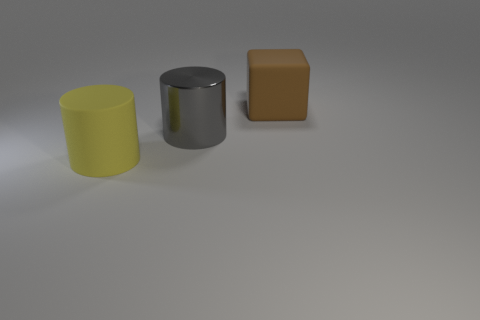What is the material of the gray thing?
Your answer should be compact. Metal. There is a gray cylinder that is the same size as the brown rubber object; what is it made of?
Your response must be concise. Metal. Is there a gray cube of the same size as the yellow matte object?
Your answer should be compact. No. Are there the same number of large yellow rubber cylinders that are in front of the large yellow matte cylinder and yellow matte cylinders that are to the right of the gray cylinder?
Offer a terse response. Yes. Are there more large shiny cylinders than tiny blue metallic spheres?
Give a very brief answer. Yes. What number of shiny things are tiny brown things or large brown objects?
Your answer should be compact. 0. What number of large rubber cylinders have the same color as the metal cylinder?
Make the answer very short. 0. What material is the object left of the cylinder behind the object in front of the big shiny thing made of?
Offer a very short reply. Rubber. The cylinder that is behind the large matte object that is in front of the block is what color?
Your response must be concise. Gray. How many tiny things are either yellow objects or blocks?
Give a very brief answer. 0. 